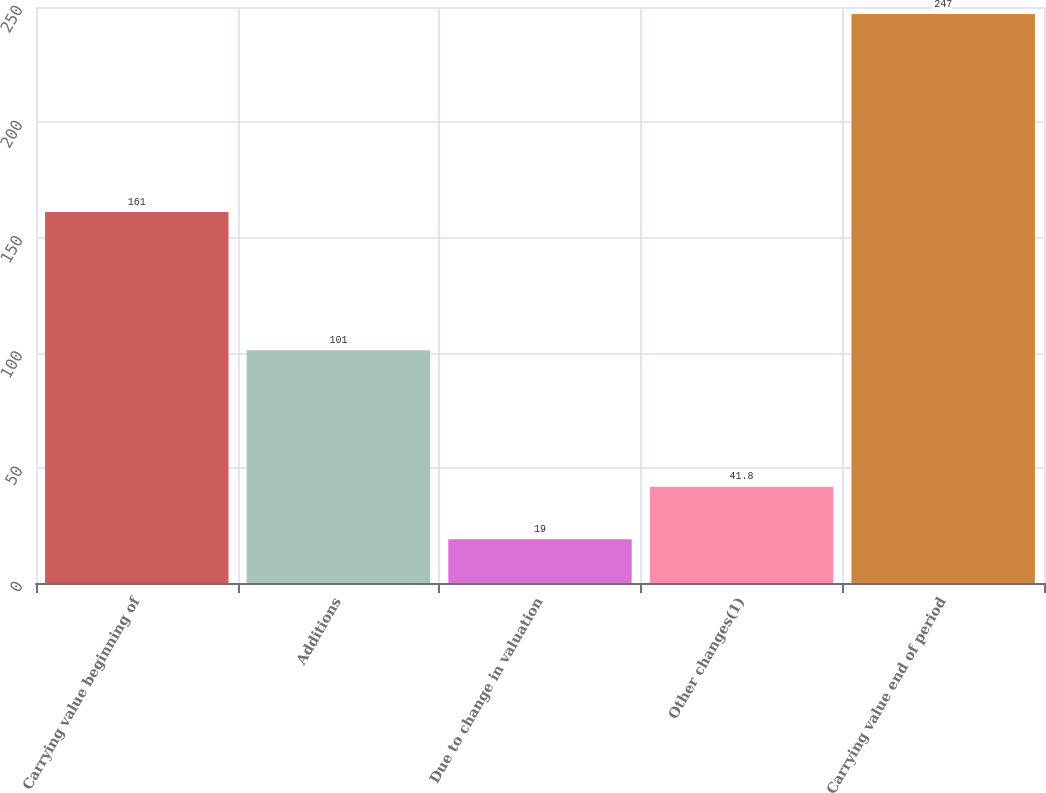Convert chart to OTSL. <chart><loc_0><loc_0><loc_500><loc_500><bar_chart><fcel>Carrying value beginning of<fcel>Additions<fcel>Due to change in valuation<fcel>Other changes(1)<fcel>Carrying value end of period<nl><fcel>161<fcel>101<fcel>19<fcel>41.8<fcel>247<nl></chart> 